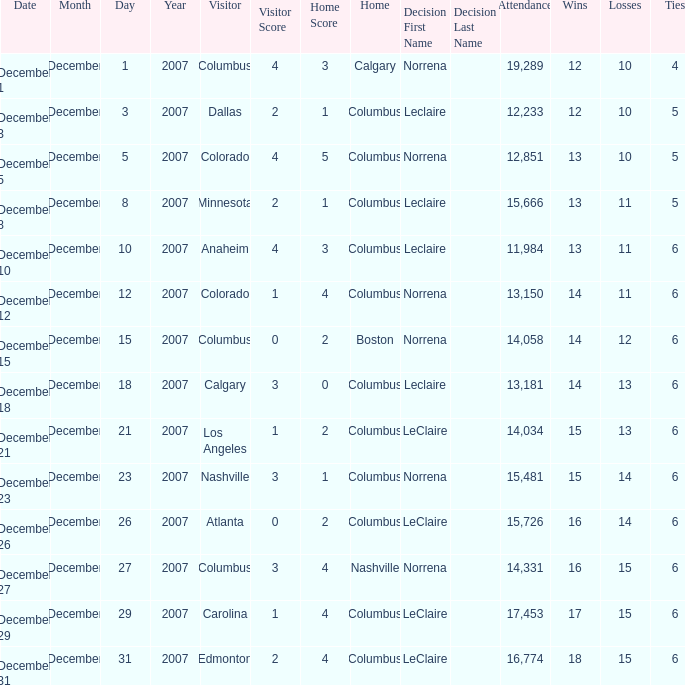What was the score with a 16–14–6 record? 0 – 2. 